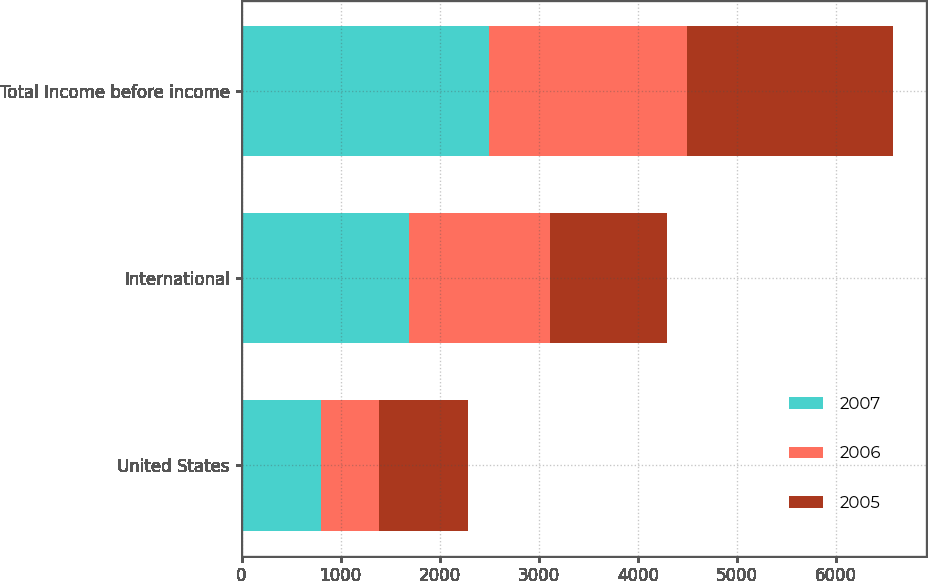Convert chart to OTSL. <chart><loc_0><loc_0><loc_500><loc_500><stacked_bar_chart><ecel><fcel>United States<fcel>International<fcel>Total Income before income<nl><fcel>2007<fcel>802.1<fcel>1694.4<fcel>2496.5<nl><fcel>2006<fcel>584.9<fcel>1416.9<fcel>2001.8<nl><fcel>2005<fcel>893.2<fcel>1185.8<fcel>2079<nl></chart> 